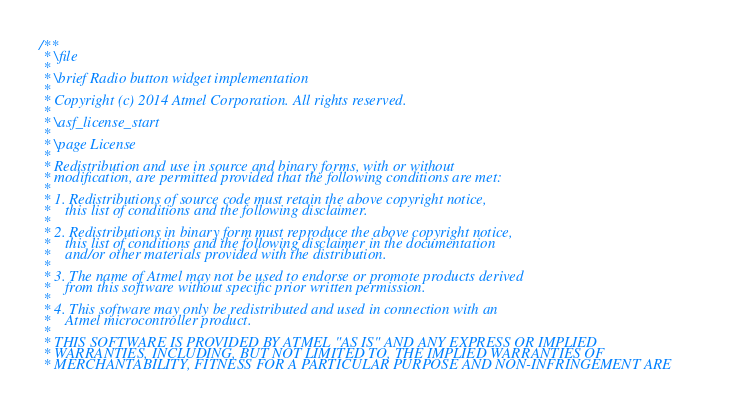Convert code to text. <code><loc_0><loc_0><loc_500><loc_500><_C_>/**
 * \file
 *
 * \brief Radio button widget implementation
 *
 * Copyright (c) 2014 Atmel Corporation. All rights reserved.
 *
 * \asf_license_start
 *
 * \page License
 *
 * Redistribution and use in source and binary forms, with or without
 * modification, are permitted provided that the following conditions are met:
 *
 * 1. Redistributions of source code must retain the above copyright notice,
 *    this list of conditions and the following disclaimer.
 *
 * 2. Redistributions in binary form must reproduce the above copyright notice,
 *    this list of conditions and the following disclaimer in the documentation
 *    and/or other materials provided with the distribution.
 *
 * 3. The name of Atmel may not be used to endorse or promote products derived
 *    from this software without specific prior written permission.
 *
 * 4. This software may only be redistributed and used in connection with an
 *    Atmel microcontroller product.
 *
 * THIS SOFTWARE IS PROVIDED BY ATMEL "AS IS" AND ANY EXPRESS OR IMPLIED
 * WARRANTIES, INCLUDING, BUT NOT LIMITED TO, THE IMPLIED WARRANTIES OF
 * MERCHANTABILITY, FITNESS FOR A PARTICULAR PURPOSE AND NON-INFRINGEMENT ARE</code> 